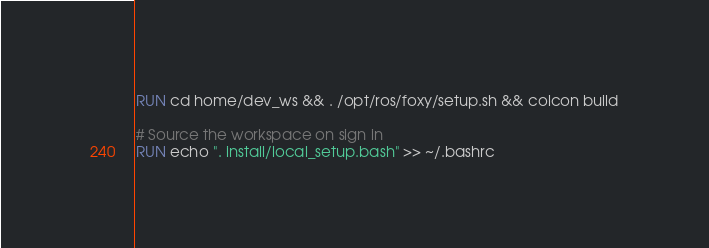<code> <loc_0><loc_0><loc_500><loc_500><_Dockerfile_>RUN cd home/dev_ws && . /opt/ros/foxy/setup.sh && colcon build

# Source the workspace on sign in
RUN echo ". install/local_setup.bash" >> ~/.bashrc
</code> 